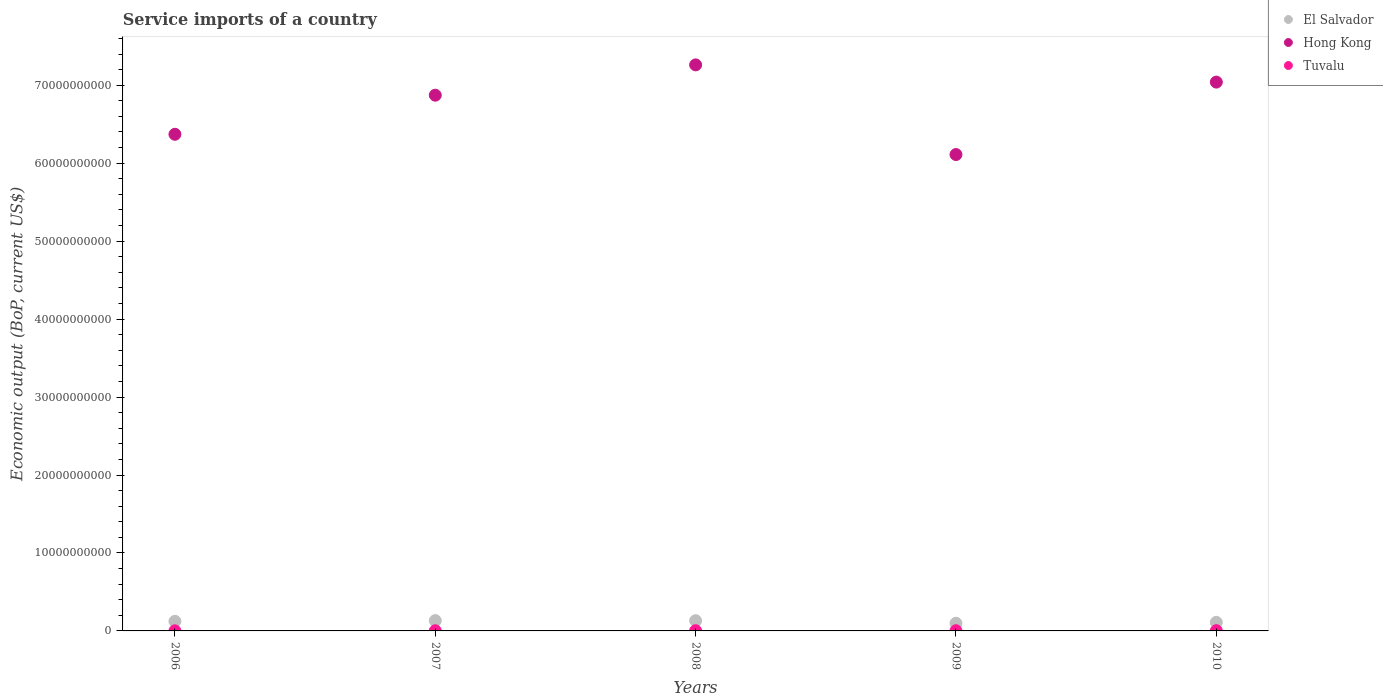How many different coloured dotlines are there?
Your answer should be compact. 3. What is the service imports in Hong Kong in 2007?
Make the answer very short. 6.87e+1. Across all years, what is the maximum service imports in Tuvalu?
Your answer should be very brief. 3.38e+07. Across all years, what is the minimum service imports in Tuvalu?
Keep it short and to the point. 1.18e+07. In which year was the service imports in Hong Kong maximum?
Your answer should be compact. 2008. What is the total service imports in El Salvador in the graph?
Offer a very short reply. 5.95e+09. What is the difference between the service imports in Hong Kong in 2007 and that in 2008?
Keep it short and to the point. -3.89e+09. What is the difference between the service imports in El Salvador in 2008 and the service imports in Tuvalu in 2010?
Give a very brief answer. 1.28e+09. What is the average service imports in Hong Kong per year?
Offer a very short reply. 6.73e+1. In the year 2009, what is the difference between the service imports in Tuvalu and service imports in El Salvador?
Provide a succinct answer. -9.57e+08. What is the ratio of the service imports in El Salvador in 2006 to that in 2009?
Your answer should be compact. 1.25. Is the service imports in El Salvador in 2009 less than that in 2010?
Ensure brevity in your answer.  Yes. What is the difference between the highest and the second highest service imports in El Salvador?
Provide a succinct answer. 1.06e+07. What is the difference between the highest and the lowest service imports in El Salvador?
Provide a succinct answer. 3.37e+08. Is the sum of the service imports in El Salvador in 2006 and 2007 greater than the maximum service imports in Tuvalu across all years?
Make the answer very short. Yes. Is it the case that in every year, the sum of the service imports in Hong Kong and service imports in El Salvador  is greater than the service imports in Tuvalu?
Offer a terse response. Yes. Is the service imports in Hong Kong strictly greater than the service imports in Tuvalu over the years?
Provide a succinct answer. Yes. Is the service imports in El Salvador strictly less than the service imports in Tuvalu over the years?
Ensure brevity in your answer.  No. Are the values on the major ticks of Y-axis written in scientific E-notation?
Make the answer very short. No. Does the graph contain grids?
Make the answer very short. No. How many legend labels are there?
Provide a succinct answer. 3. What is the title of the graph?
Ensure brevity in your answer.  Service imports of a country. Does "Burundi" appear as one of the legend labels in the graph?
Offer a very short reply. No. What is the label or title of the X-axis?
Provide a short and direct response. Years. What is the label or title of the Y-axis?
Keep it short and to the point. Economic output (BoP, current US$). What is the Economic output (BoP, current US$) of El Salvador in 2006?
Ensure brevity in your answer.  1.23e+09. What is the Economic output (BoP, current US$) of Hong Kong in 2006?
Your answer should be very brief. 6.37e+1. What is the Economic output (BoP, current US$) in Tuvalu in 2006?
Offer a terse response. 1.18e+07. What is the Economic output (BoP, current US$) in El Salvador in 2007?
Provide a short and direct response. 1.32e+09. What is the Economic output (BoP, current US$) of Hong Kong in 2007?
Ensure brevity in your answer.  6.87e+1. What is the Economic output (BoP, current US$) of Tuvalu in 2007?
Your answer should be compact. 2.19e+07. What is the Economic output (BoP, current US$) of El Salvador in 2008?
Provide a short and direct response. 1.31e+09. What is the Economic output (BoP, current US$) of Hong Kong in 2008?
Give a very brief answer. 7.26e+1. What is the Economic output (BoP, current US$) of Tuvalu in 2008?
Offer a terse response. 2.99e+07. What is the Economic output (BoP, current US$) of El Salvador in 2009?
Provide a succinct answer. 9.84e+08. What is the Economic output (BoP, current US$) of Hong Kong in 2009?
Keep it short and to the point. 6.11e+1. What is the Economic output (BoP, current US$) in Tuvalu in 2009?
Provide a succinct answer. 2.70e+07. What is the Economic output (BoP, current US$) in El Salvador in 2010?
Give a very brief answer. 1.10e+09. What is the Economic output (BoP, current US$) in Hong Kong in 2010?
Offer a terse response. 7.04e+1. What is the Economic output (BoP, current US$) in Tuvalu in 2010?
Ensure brevity in your answer.  3.38e+07. Across all years, what is the maximum Economic output (BoP, current US$) of El Salvador?
Offer a very short reply. 1.32e+09. Across all years, what is the maximum Economic output (BoP, current US$) of Hong Kong?
Provide a short and direct response. 7.26e+1. Across all years, what is the maximum Economic output (BoP, current US$) of Tuvalu?
Your answer should be very brief. 3.38e+07. Across all years, what is the minimum Economic output (BoP, current US$) in El Salvador?
Offer a terse response. 9.84e+08. Across all years, what is the minimum Economic output (BoP, current US$) of Hong Kong?
Make the answer very short. 6.11e+1. Across all years, what is the minimum Economic output (BoP, current US$) in Tuvalu?
Give a very brief answer. 1.18e+07. What is the total Economic output (BoP, current US$) in El Salvador in the graph?
Your answer should be compact. 5.95e+09. What is the total Economic output (BoP, current US$) in Hong Kong in the graph?
Your response must be concise. 3.37e+11. What is the total Economic output (BoP, current US$) of Tuvalu in the graph?
Provide a succinct answer. 1.24e+08. What is the difference between the Economic output (BoP, current US$) of El Salvador in 2006 and that in 2007?
Offer a very short reply. -8.94e+07. What is the difference between the Economic output (BoP, current US$) in Hong Kong in 2006 and that in 2007?
Offer a very short reply. -5.01e+09. What is the difference between the Economic output (BoP, current US$) of Tuvalu in 2006 and that in 2007?
Give a very brief answer. -1.01e+07. What is the difference between the Economic output (BoP, current US$) in El Salvador in 2006 and that in 2008?
Offer a very short reply. -7.88e+07. What is the difference between the Economic output (BoP, current US$) of Hong Kong in 2006 and that in 2008?
Your response must be concise. -8.90e+09. What is the difference between the Economic output (BoP, current US$) of Tuvalu in 2006 and that in 2008?
Offer a terse response. -1.81e+07. What is the difference between the Economic output (BoP, current US$) of El Salvador in 2006 and that in 2009?
Keep it short and to the point. 2.48e+08. What is the difference between the Economic output (BoP, current US$) of Hong Kong in 2006 and that in 2009?
Make the answer very short. 2.60e+09. What is the difference between the Economic output (BoP, current US$) in Tuvalu in 2006 and that in 2009?
Keep it short and to the point. -1.52e+07. What is the difference between the Economic output (BoP, current US$) of El Salvador in 2006 and that in 2010?
Provide a short and direct response. 1.32e+08. What is the difference between the Economic output (BoP, current US$) of Hong Kong in 2006 and that in 2010?
Provide a short and direct response. -6.69e+09. What is the difference between the Economic output (BoP, current US$) of Tuvalu in 2006 and that in 2010?
Offer a very short reply. -2.20e+07. What is the difference between the Economic output (BoP, current US$) of El Salvador in 2007 and that in 2008?
Provide a short and direct response. 1.06e+07. What is the difference between the Economic output (BoP, current US$) in Hong Kong in 2007 and that in 2008?
Make the answer very short. -3.89e+09. What is the difference between the Economic output (BoP, current US$) in Tuvalu in 2007 and that in 2008?
Keep it short and to the point. -8.02e+06. What is the difference between the Economic output (BoP, current US$) of El Salvador in 2007 and that in 2009?
Your response must be concise. 3.37e+08. What is the difference between the Economic output (BoP, current US$) of Hong Kong in 2007 and that in 2009?
Offer a very short reply. 7.61e+09. What is the difference between the Economic output (BoP, current US$) of Tuvalu in 2007 and that in 2009?
Your answer should be compact. -5.16e+06. What is the difference between the Economic output (BoP, current US$) of El Salvador in 2007 and that in 2010?
Offer a terse response. 2.22e+08. What is the difference between the Economic output (BoP, current US$) of Hong Kong in 2007 and that in 2010?
Your answer should be compact. -1.68e+09. What is the difference between the Economic output (BoP, current US$) in Tuvalu in 2007 and that in 2010?
Ensure brevity in your answer.  -1.20e+07. What is the difference between the Economic output (BoP, current US$) of El Salvador in 2008 and that in 2009?
Give a very brief answer. 3.27e+08. What is the difference between the Economic output (BoP, current US$) in Hong Kong in 2008 and that in 2009?
Provide a short and direct response. 1.15e+1. What is the difference between the Economic output (BoP, current US$) in Tuvalu in 2008 and that in 2009?
Your answer should be very brief. 2.86e+06. What is the difference between the Economic output (BoP, current US$) of El Salvador in 2008 and that in 2010?
Provide a succinct answer. 2.11e+08. What is the difference between the Economic output (BoP, current US$) in Hong Kong in 2008 and that in 2010?
Your answer should be compact. 2.21e+09. What is the difference between the Economic output (BoP, current US$) of Tuvalu in 2008 and that in 2010?
Provide a short and direct response. -3.95e+06. What is the difference between the Economic output (BoP, current US$) of El Salvador in 2009 and that in 2010?
Give a very brief answer. -1.16e+08. What is the difference between the Economic output (BoP, current US$) of Hong Kong in 2009 and that in 2010?
Offer a terse response. -9.29e+09. What is the difference between the Economic output (BoP, current US$) in Tuvalu in 2009 and that in 2010?
Keep it short and to the point. -6.81e+06. What is the difference between the Economic output (BoP, current US$) of El Salvador in 2006 and the Economic output (BoP, current US$) of Hong Kong in 2007?
Provide a short and direct response. -6.75e+1. What is the difference between the Economic output (BoP, current US$) in El Salvador in 2006 and the Economic output (BoP, current US$) in Tuvalu in 2007?
Your answer should be compact. 1.21e+09. What is the difference between the Economic output (BoP, current US$) in Hong Kong in 2006 and the Economic output (BoP, current US$) in Tuvalu in 2007?
Your answer should be compact. 6.37e+1. What is the difference between the Economic output (BoP, current US$) of El Salvador in 2006 and the Economic output (BoP, current US$) of Hong Kong in 2008?
Make the answer very short. -7.14e+1. What is the difference between the Economic output (BoP, current US$) in El Salvador in 2006 and the Economic output (BoP, current US$) in Tuvalu in 2008?
Keep it short and to the point. 1.20e+09. What is the difference between the Economic output (BoP, current US$) of Hong Kong in 2006 and the Economic output (BoP, current US$) of Tuvalu in 2008?
Ensure brevity in your answer.  6.37e+1. What is the difference between the Economic output (BoP, current US$) of El Salvador in 2006 and the Economic output (BoP, current US$) of Hong Kong in 2009?
Provide a short and direct response. -5.99e+1. What is the difference between the Economic output (BoP, current US$) in El Salvador in 2006 and the Economic output (BoP, current US$) in Tuvalu in 2009?
Ensure brevity in your answer.  1.20e+09. What is the difference between the Economic output (BoP, current US$) of Hong Kong in 2006 and the Economic output (BoP, current US$) of Tuvalu in 2009?
Your response must be concise. 6.37e+1. What is the difference between the Economic output (BoP, current US$) of El Salvador in 2006 and the Economic output (BoP, current US$) of Hong Kong in 2010?
Your answer should be compact. -6.92e+1. What is the difference between the Economic output (BoP, current US$) of El Salvador in 2006 and the Economic output (BoP, current US$) of Tuvalu in 2010?
Your answer should be very brief. 1.20e+09. What is the difference between the Economic output (BoP, current US$) of Hong Kong in 2006 and the Economic output (BoP, current US$) of Tuvalu in 2010?
Keep it short and to the point. 6.37e+1. What is the difference between the Economic output (BoP, current US$) in El Salvador in 2007 and the Economic output (BoP, current US$) in Hong Kong in 2008?
Keep it short and to the point. -7.13e+1. What is the difference between the Economic output (BoP, current US$) in El Salvador in 2007 and the Economic output (BoP, current US$) in Tuvalu in 2008?
Keep it short and to the point. 1.29e+09. What is the difference between the Economic output (BoP, current US$) of Hong Kong in 2007 and the Economic output (BoP, current US$) of Tuvalu in 2008?
Your answer should be very brief. 6.87e+1. What is the difference between the Economic output (BoP, current US$) in El Salvador in 2007 and the Economic output (BoP, current US$) in Hong Kong in 2009?
Offer a very short reply. -5.98e+1. What is the difference between the Economic output (BoP, current US$) of El Salvador in 2007 and the Economic output (BoP, current US$) of Tuvalu in 2009?
Your response must be concise. 1.29e+09. What is the difference between the Economic output (BoP, current US$) of Hong Kong in 2007 and the Economic output (BoP, current US$) of Tuvalu in 2009?
Make the answer very short. 6.87e+1. What is the difference between the Economic output (BoP, current US$) of El Salvador in 2007 and the Economic output (BoP, current US$) of Hong Kong in 2010?
Provide a short and direct response. -6.91e+1. What is the difference between the Economic output (BoP, current US$) in El Salvador in 2007 and the Economic output (BoP, current US$) in Tuvalu in 2010?
Your answer should be very brief. 1.29e+09. What is the difference between the Economic output (BoP, current US$) in Hong Kong in 2007 and the Economic output (BoP, current US$) in Tuvalu in 2010?
Give a very brief answer. 6.87e+1. What is the difference between the Economic output (BoP, current US$) in El Salvador in 2008 and the Economic output (BoP, current US$) in Hong Kong in 2009?
Offer a terse response. -5.98e+1. What is the difference between the Economic output (BoP, current US$) of El Salvador in 2008 and the Economic output (BoP, current US$) of Tuvalu in 2009?
Make the answer very short. 1.28e+09. What is the difference between the Economic output (BoP, current US$) of Hong Kong in 2008 and the Economic output (BoP, current US$) of Tuvalu in 2009?
Give a very brief answer. 7.26e+1. What is the difference between the Economic output (BoP, current US$) in El Salvador in 2008 and the Economic output (BoP, current US$) in Hong Kong in 2010?
Provide a short and direct response. -6.91e+1. What is the difference between the Economic output (BoP, current US$) of El Salvador in 2008 and the Economic output (BoP, current US$) of Tuvalu in 2010?
Keep it short and to the point. 1.28e+09. What is the difference between the Economic output (BoP, current US$) in Hong Kong in 2008 and the Economic output (BoP, current US$) in Tuvalu in 2010?
Offer a very short reply. 7.26e+1. What is the difference between the Economic output (BoP, current US$) in El Salvador in 2009 and the Economic output (BoP, current US$) in Hong Kong in 2010?
Your response must be concise. -6.94e+1. What is the difference between the Economic output (BoP, current US$) of El Salvador in 2009 and the Economic output (BoP, current US$) of Tuvalu in 2010?
Keep it short and to the point. 9.50e+08. What is the difference between the Economic output (BoP, current US$) in Hong Kong in 2009 and the Economic output (BoP, current US$) in Tuvalu in 2010?
Provide a short and direct response. 6.11e+1. What is the average Economic output (BoP, current US$) of El Salvador per year?
Ensure brevity in your answer.  1.19e+09. What is the average Economic output (BoP, current US$) in Hong Kong per year?
Your answer should be very brief. 6.73e+1. What is the average Economic output (BoP, current US$) of Tuvalu per year?
Offer a terse response. 2.49e+07. In the year 2006, what is the difference between the Economic output (BoP, current US$) in El Salvador and Economic output (BoP, current US$) in Hong Kong?
Provide a succinct answer. -6.25e+1. In the year 2006, what is the difference between the Economic output (BoP, current US$) of El Salvador and Economic output (BoP, current US$) of Tuvalu?
Provide a short and direct response. 1.22e+09. In the year 2006, what is the difference between the Economic output (BoP, current US$) of Hong Kong and Economic output (BoP, current US$) of Tuvalu?
Offer a very short reply. 6.37e+1. In the year 2007, what is the difference between the Economic output (BoP, current US$) in El Salvador and Economic output (BoP, current US$) in Hong Kong?
Offer a terse response. -6.74e+1. In the year 2007, what is the difference between the Economic output (BoP, current US$) in El Salvador and Economic output (BoP, current US$) in Tuvalu?
Provide a succinct answer. 1.30e+09. In the year 2007, what is the difference between the Economic output (BoP, current US$) of Hong Kong and Economic output (BoP, current US$) of Tuvalu?
Ensure brevity in your answer.  6.87e+1. In the year 2008, what is the difference between the Economic output (BoP, current US$) of El Salvador and Economic output (BoP, current US$) of Hong Kong?
Offer a terse response. -7.13e+1. In the year 2008, what is the difference between the Economic output (BoP, current US$) of El Salvador and Economic output (BoP, current US$) of Tuvalu?
Provide a succinct answer. 1.28e+09. In the year 2008, what is the difference between the Economic output (BoP, current US$) of Hong Kong and Economic output (BoP, current US$) of Tuvalu?
Offer a very short reply. 7.26e+1. In the year 2009, what is the difference between the Economic output (BoP, current US$) in El Salvador and Economic output (BoP, current US$) in Hong Kong?
Provide a succinct answer. -6.01e+1. In the year 2009, what is the difference between the Economic output (BoP, current US$) in El Salvador and Economic output (BoP, current US$) in Tuvalu?
Offer a terse response. 9.57e+08. In the year 2009, what is the difference between the Economic output (BoP, current US$) in Hong Kong and Economic output (BoP, current US$) in Tuvalu?
Keep it short and to the point. 6.11e+1. In the year 2010, what is the difference between the Economic output (BoP, current US$) of El Salvador and Economic output (BoP, current US$) of Hong Kong?
Your answer should be very brief. -6.93e+1. In the year 2010, what is the difference between the Economic output (BoP, current US$) in El Salvador and Economic output (BoP, current US$) in Tuvalu?
Offer a terse response. 1.07e+09. In the year 2010, what is the difference between the Economic output (BoP, current US$) in Hong Kong and Economic output (BoP, current US$) in Tuvalu?
Offer a very short reply. 7.04e+1. What is the ratio of the Economic output (BoP, current US$) of El Salvador in 2006 to that in 2007?
Keep it short and to the point. 0.93. What is the ratio of the Economic output (BoP, current US$) in Hong Kong in 2006 to that in 2007?
Your answer should be very brief. 0.93. What is the ratio of the Economic output (BoP, current US$) in Tuvalu in 2006 to that in 2007?
Ensure brevity in your answer.  0.54. What is the ratio of the Economic output (BoP, current US$) of El Salvador in 2006 to that in 2008?
Offer a very short reply. 0.94. What is the ratio of the Economic output (BoP, current US$) of Hong Kong in 2006 to that in 2008?
Offer a very short reply. 0.88. What is the ratio of the Economic output (BoP, current US$) of Tuvalu in 2006 to that in 2008?
Provide a short and direct response. 0.39. What is the ratio of the Economic output (BoP, current US$) in El Salvador in 2006 to that in 2009?
Your answer should be compact. 1.25. What is the ratio of the Economic output (BoP, current US$) of Hong Kong in 2006 to that in 2009?
Make the answer very short. 1.04. What is the ratio of the Economic output (BoP, current US$) of Tuvalu in 2006 to that in 2009?
Your answer should be very brief. 0.44. What is the ratio of the Economic output (BoP, current US$) in El Salvador in 2006 to that in 2010?
Your answer should be very brief. 1.12. What is the ratio of the Economic output (BoP, current US$) in Hong Kong in 2006 to that in 2010?
Provide a succinct answer. 0.9. What is the ratio of the Economic output (BoP, current US$) of Tuvalu in 2006 to that in 2010?
Offer a very short reply. 0.35. What is the ratio of the Economic output (BoP, current US$) in Hong Kong in 2007 to that in 2008?
Keep it short and to the point. 0.95. What is the ratio of the Economic output (BoP, current US$) of Tuvalu in 2007 to that in 2008?
Give a very brief answer. 0.73. What is the ratio of the Economic output (BoP, current US$) of El Salvador in 2007 to that in 2009?
Your answer should be compact. 1.34. What is the ratio of the Economic output (BoP, current US$) in Hong Kong in 2007 to that in 2009?
Provide a short and direct response. 1.12. What is the ratio of the Economic output (BoP, current US$) in Tuvalu in 2007 to that in 2009?
Keep it short and to the point. 0.81. What is the ratio of the Economic output (BoP, current US$) of El Salvador in 2007 to that in 2010?
Provide a succinct answer. 1.2. What is the ratio of the Economic output (BoP, current US$) of Hong Kong in 2007 to that in 2010?
Your answer should be compact. 0.98. What is the ratio of the Economic output (BoP, current US$) in Tuvalu in 2007 to that in 2010?
Ensure brevity in your answer.  0.65. What is the ratio of the Economic output (BoP, current US$) in El Salvador in 2008 to that in 2009?
Make the answer very short. 1.33. What is the ratio of the Economic output (BoP, current US$) in Hong Kong in 2008 to that in 2009?
Keep it short and to the point. 1.19. What is the ratio of the Economic output (BoP, current US$) in Tuvalu in 2008 to that in 2009?
Offer a terse response. 1.11. What is the ratio of the Economic output (BoP, current US$) of El Salvador in 2008 to that in 2010?
Provide a short and direct response. 1.19. What is the ratio of the Economic output (BoP, current US$) in Hong Kong in 2008 to that in 2010?
Your answer should be very brief. 1.03. What is the ratio of the Economic output (BoP, current US$) of Tuvalu in 2008 to that in 2010?
Make the answer very short. 0.88. What is the ratio of the Economic output (BoP, current US$) in El Salvador in 2009 to that in 2010?
Give a very brief answer. 0.89. What is the ratio of the Economic output (BoP, current US$) in Hong Kong in 2009 to that in 2010?
Give a very brief answer. 0.87. What is the ratio of the Economic output (BoP, current US$) in Tuvalu in 2009 to that in 2010?
Your answer should be very brief. 0.8. What is the difference between the highest and the second highest Economic output (BoP, current US$) of El Salvador?
Your answer should be very brief. 1.06e+07. What is the difference between the highest and the second highest Economic output (BoP, current US$) in Hong Kong?
Make the answer very short. 2.21e+09. What is the difference between the highest and the second highest Economic output (BoP, current US$) in Tuvalu?
Ensure brevity in your answer.  3.95e+06. What is the difference between the highest and the lowest Economic output (BoP, current US$) of El Salvador?
Offer a terse response. 3.37e+08. What is the difference between the highest and the lowest Economic output (BoP, current US$) of Hong Kong?
Make the answer very short. 1.15e+1. What is the difference between the highest and the lowest Economic output (BoP, current US$) of Tuvalu?
Keep it short and to the point. 2.20e+07. 